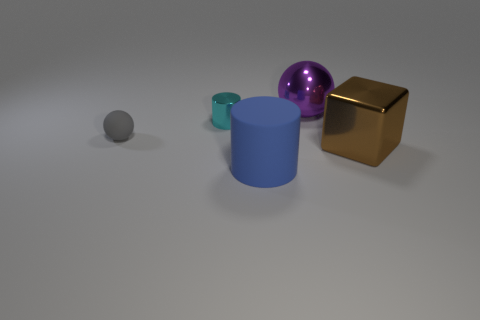There is a sphere left of the metallic cylinder; does it have the same size as the big brown shiny block?
Offer a very short reply. No. What number of spheres are either blue things or large metallic objects?
Provide a succinct answer. 1. What is the material of the thing in front of the metallic block?
Provide a short and direct response. Rubber. Is the number of large red cylinders less than the number of large blocks?
Offer a terse response. Yes. What is the size of the object that is behind the cube and in front of the cyan metal object?
Make the answer very short. Small. There is a sphere right of the rubber object that is on the right side of the object on the left side of the cyan metal thing; what is its size?
Give a very brief answer. Large. How many other things are there of the same color as the tiny metal thing?
Make the answer very short. 0. There is a cylinder that is behind the large blue matte cylinder; is its color the same as the big cylinder?
Your response must be concise. No. How many objects are cyan metal spheres or big metal balls?
Provide a short and direct response. 1. The ball in front of the large purple sphere is what color?
Provide a short and direct response. Gray. 